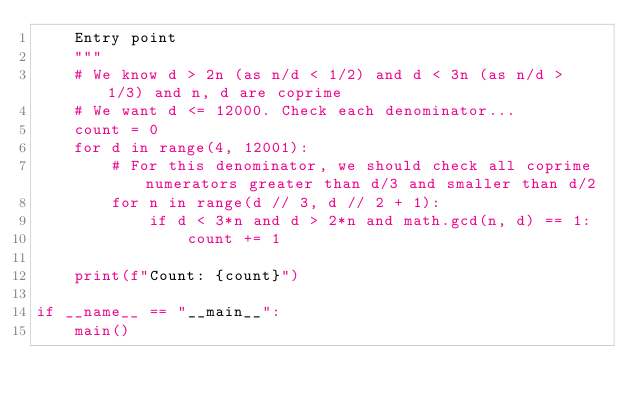<code> <loc_0><loc_0><loc_500><loc_500><_Python_>    Entry point
    """
    # We know d > 2n (as n/d < 1/2) and d < 3n (as n/d > 1/3) and n, d are coprime
    # We want d <= 12000. Check each denominator...
    count = 0
    for d in range(4, 12001):
        # For this denominator, we should check all coprime numerators greater than d/3 and smaller than d/2
        for n in range(d // 3, d // 2 + 1):
            if d < 3*n and d > 2*n and math.gcd(n, d) == 1:
                count += 1

    print(f"Count: {count}")

if __name__ == "__main__":
    main()
</code> 